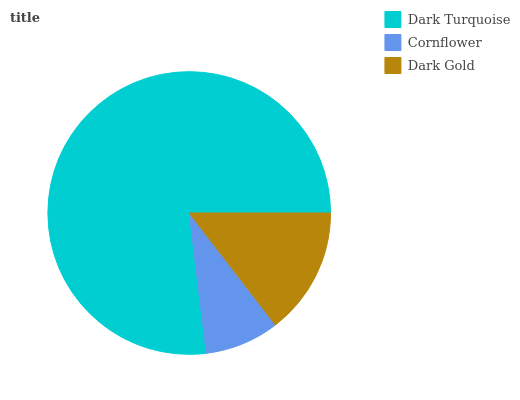Is Cornflower the minimum?
Answer yes or no. Yes. Is Dark Turquoise the maximum?
Answer yes or no. Yes. Is Dark Gold the minimum?
Answer yes or no. No. Is Dark Gold the maximum?
Answer yes or no. No. Is Dark Gold greater than Cornflower?
Answer yes or no. Yes. Is Cornflower less than Dark Gold?
Answer yes or no. Yes. Is Cornflower greater than Dark Gold?
Answer yes or no. No. Is Dark Gold less than Cornflower?
Answer yes or no. No. Is Dark Gold the high median?
Answer yes or no. Yes. Is Dark Gold the low median?
Answer yes or no. Yes. Is Dark Turquoise the high median?
Answer yes or no. No. Is Dark Turquoise the low median?
Answer yes or no. No. 